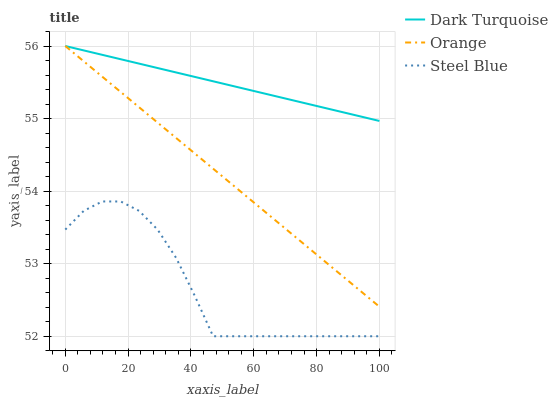Does Steel Blue have the minimum area under the curve?
Answer yes or no. Yes. Does Dark Turquoise have the maximum area under the curve?
Answer yes or no. Yes. Does Dark Turquoise have the minimum area under the curve?
Answer yes or no. No. Does Steel Blue have the maximum area under the curve?
Answer yes or no. No. Is Orange the smoothest?
Answer yes or no. Yes. Is Steel Blue the roughest?
Answer yes or no. Yes. Is Dark Turquoise the smoothest?
Answer yes or no. No. Is Dark Turquoise the roughest?
Answer yes or no. No. Does Steel Blue have the lowest value?
Answer yes or no. Yes. Does Dark Turquoise have the lowest value?
Answer yes or no. No. Does Dark Turquoise have the highest value?
Answer yes or no. Yes. Does Steel Blue have the highest value?
Answer yes or no. No. Is Steel Blue less than Dark Turquoise?
Answer yes or no. Yes. Is Dark Turquoise greater than Steel Blue?
Answer yes or no. Yes. Does Orange intersect Dark Turquoise?
Answer yes or no. Yes. Is Orange less than Dark Turquoise?
Answer yes or no. No. Is Orange greater than Dark Turquoise?
Answer yes or no. No. Does Steel Blue intersect Dark Turquoise?
Answer yes or no. No. 